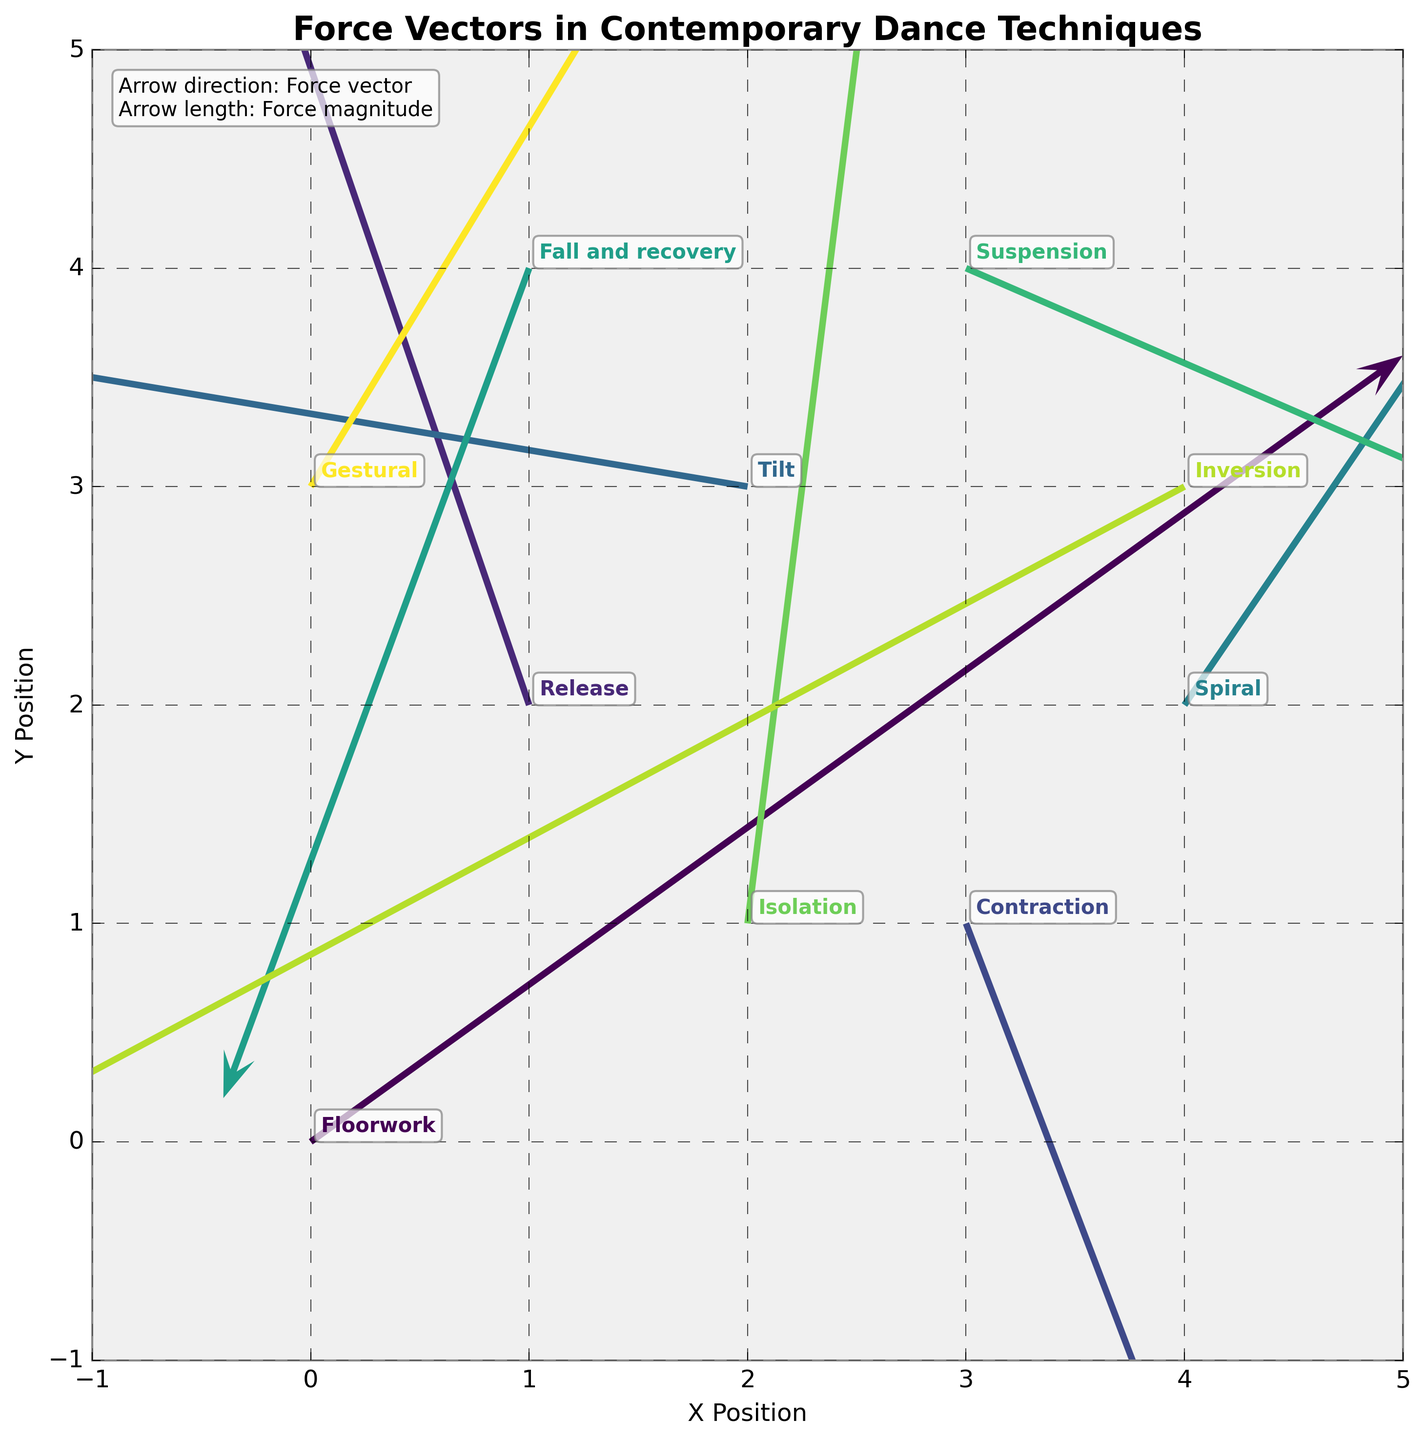What is the title of the plot? The title is placed at the top of the plot. By examining there, you can easily identify the title.
Answer: "Force Vectors in Contemporary Dance Techniques" How many different dance techniques are represented in the plot? Each technique is annotated next to the arrows. Counting these annotations gives the number of techniques.
Answer: 10 Which dance technique has the largest arrow? The arrow's length corresponds to the force magnitude. Observe and compare all the arrows' lengths to determine the longest one.
Answer: Release What is the color scheme used in the plot? The color scheme is derived from the colormap, which in this case is Viridis. Notice the gradient of colors from green to purple used in the arrows and annotations.
Answer: Viridis How is the Spiral technique represented in terms of force direction and magnitude? Locate the annotation for Spiral, then observe the corresponding arrow's direction and length. The arrow points rightward and upward, indicating positive force in both x and y directions.
Answer: (1.5, 2.2) Which technique exhibits a force similar in direction but larger in magnitude compared to the Gestural technique? First, identify the arrow for Gestural, then find another arrow pointing in a similar direction but with a visibly larger length.
Answer: Spiral What are the x and y positions of the Isolation technique? Locate the annotation for Isolation and identify the corresponding arrow's starting point on the x and y axes.
Answer: (2, 1) Which technique has a negative x-force and a positive y-force component? Review each arrow and annotation to find where the x-component is negative (pointing left) and the y-component is positive (pointing up).
Answer: Tilt Compare the force vectors of Floorwork and Suspension in terms of direction. Which one points more downward? Locate the annotations for Floorwork and Suspension, then compare the arrows. Determine which one points more vertically downward.
Answer: Floorwork What is the vertical force component (v) for the Contraction technique? Identify the arrow linked to Contraction and read the value of the vertical component (v).
Answer: -2.1 